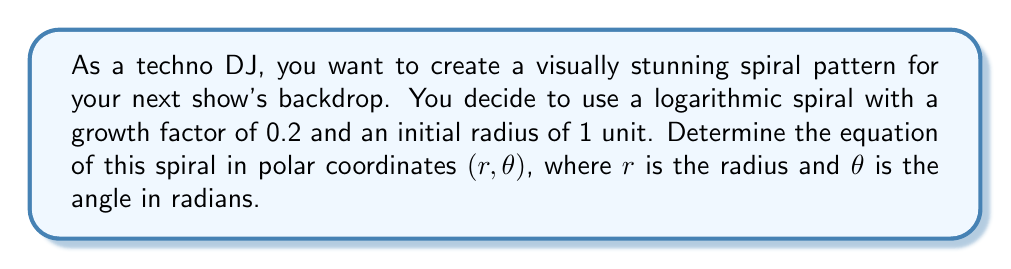Teach me how to tackle this problem. To find the equation of a logarithmic spiral in polar coordinates, we follow these steps:

1. The general form of a logarithmic spiral is:

   $$r = ae^{b\theta}$$

   where $a$ is the initial radius and $b$ is the growth factor.

2. We are given that the initial radius $a = 1$ and the growth factor $b = 0.2$.

3. Substituting these values into the general equation:

   $$r = 1 \cdot e^{0.2\theta}$$

4. Simplify:

   $$r = e^{0.2\theta}$$

This equation represents a logarithmic spiral that starts at a radius of 1 unit when $\theta = 0$ and grows exponentially as $\theta$ increases. The growth factor of 0.2 determines how tightly the spiral is wound.

[asy]
import graph;
size(200);
real r(real t) {return exp(0.2*t);}
path s=polargraph(r,0,4pi);
draw(s,blue);
xaxis("x",arrow=Arrow);
yaxis("y",arrow=Arrow);
label("$r=e^{0.2\theta}$",(3,3),E);
[/asy]
Answer: $r = e^{0.2\theta}$ 